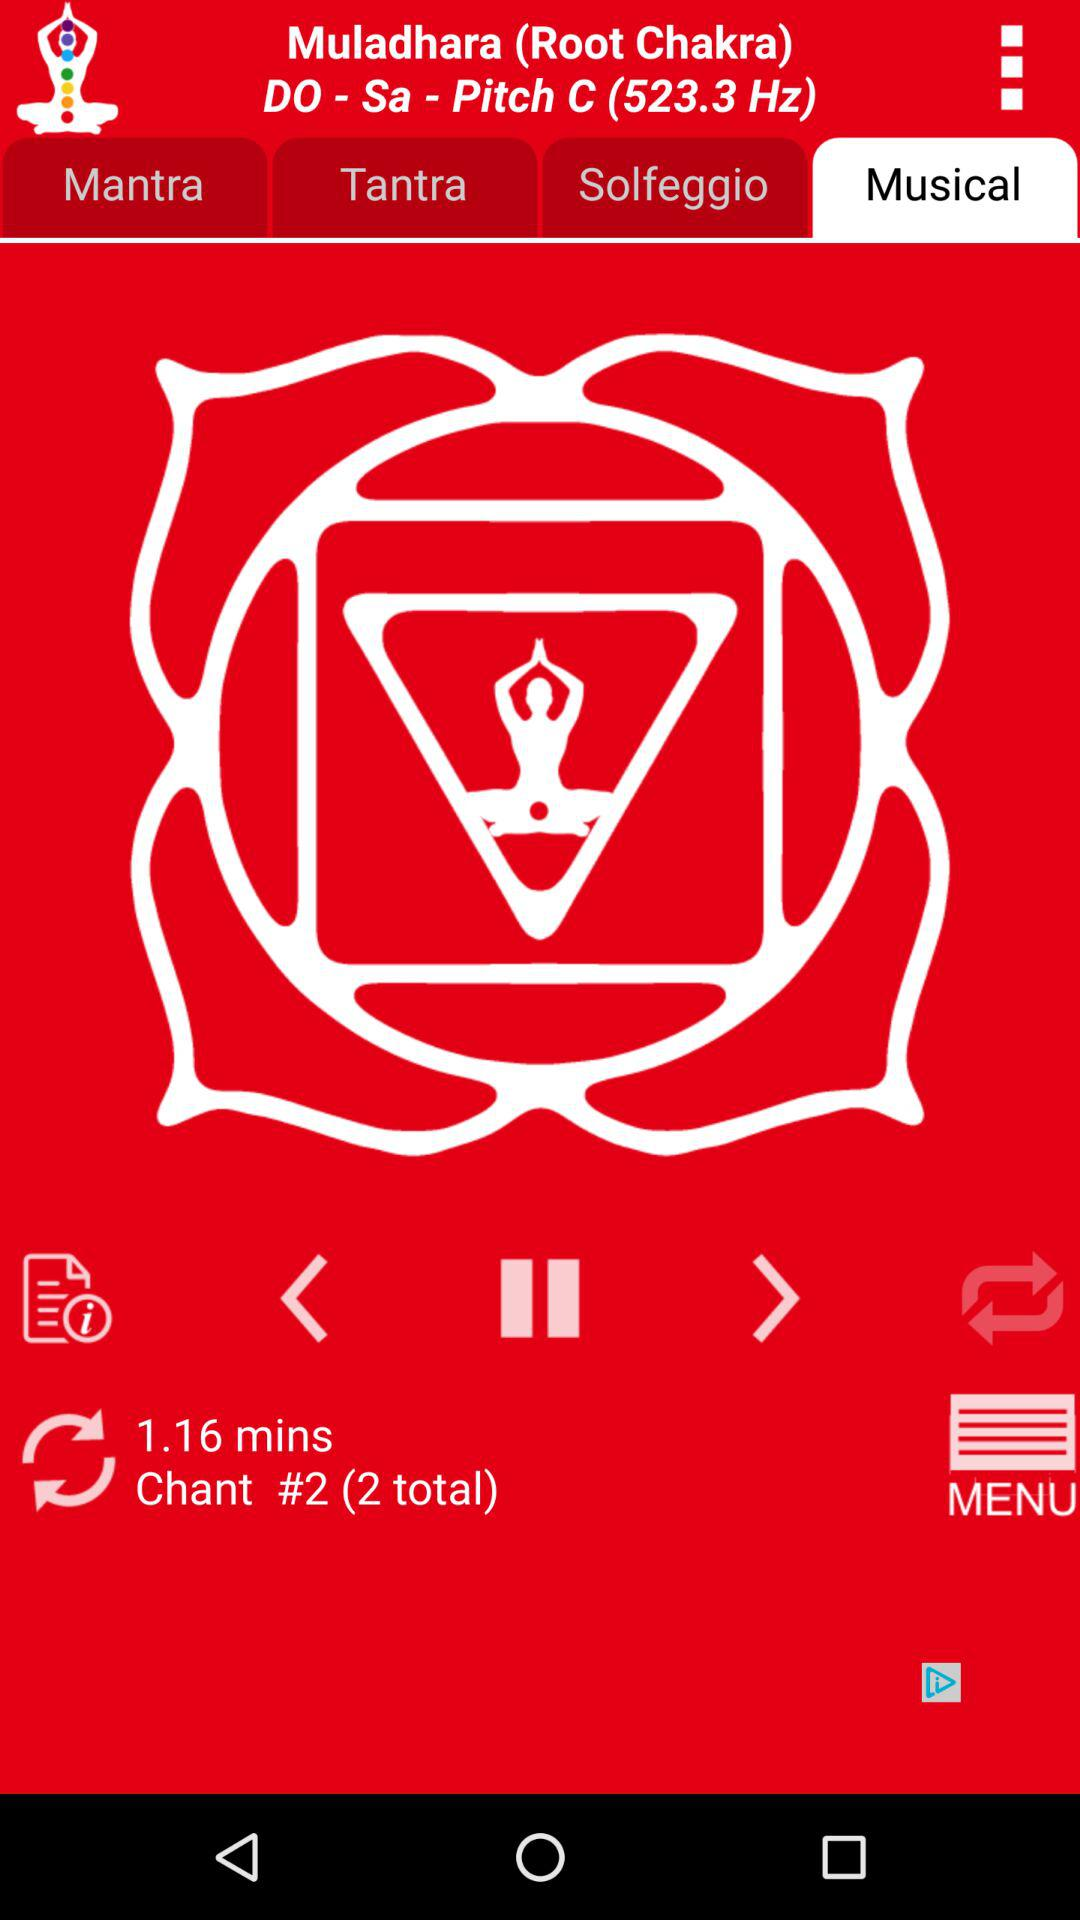Which tab is selected? The selected tab is "Musical". 